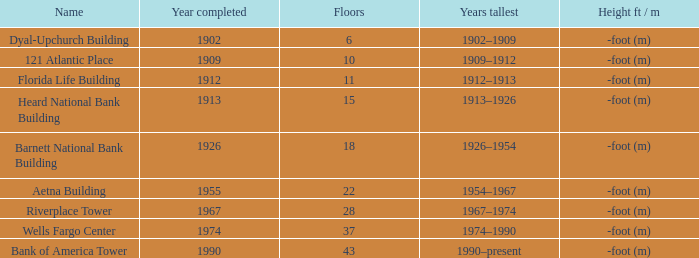Parse the full table. {'header': ['Name', 'Year completed', 'Floors', 'Years tallest', 'Height ft / m'], 'rows': [['Dyal-Upchurch Building', '1902', '6', '1902–1909', '-foot (m)'], ['121 Atlantic Place', '1909', '10', '1909–1912', '-foot (m)'], ['Florida Life Building', '1912', '11', '1912–1913', '-foot (m)'], ['Heard National Bank Building', '1913', '15', '1913–1926', '-foot (m)'], ['Barnett National Bank Building', '1926', '18', '1926–1954', '-foot (m)'], ['Aetna Building', '1955', '22', '1954–1967', '-foot (m)'], ['Riverplace Tower', '1967', '28', '1967–1974', '-foot (m)'], ['Wells Fargo Center', '1974', '37', '1974–1990', '-foot (m)'], ['Bank of America Tower', '1990', '43', '1990–present', '-foot (m)']]} How tall is the florida life building, completed before 1990? -foot (m). 